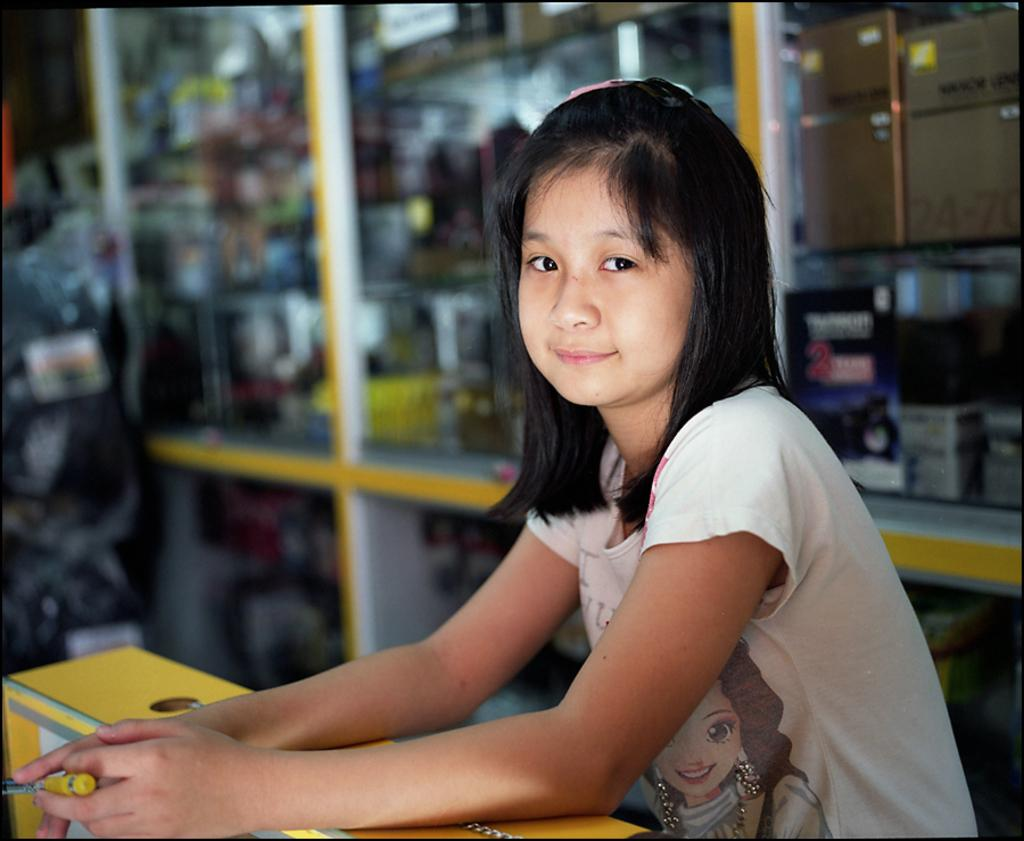Who is the main subject in the image? There is a girl in the middle of the image. What is behind the girl? There are shelves behind the girl. What is covering the shelves? The shelves are covered by glasses. What is in front of the girl? There is a table in front of the girl. What is the girl doing with her hands? The girl's hands are on the table. What type of sock is the girl wearing in the image? There is no sock visible in the image, as the girl's feet are not shown. 